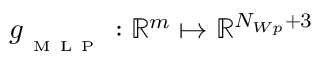Convert formula to latex. <formula><loc_0><loc_0><loc_500><loc_500>g _ { _ { M } L P } \colon \mathbb { R } ^ { m } \mapsto \mathbb { R } ^ { N _ { W p } + 3 }</formula> 